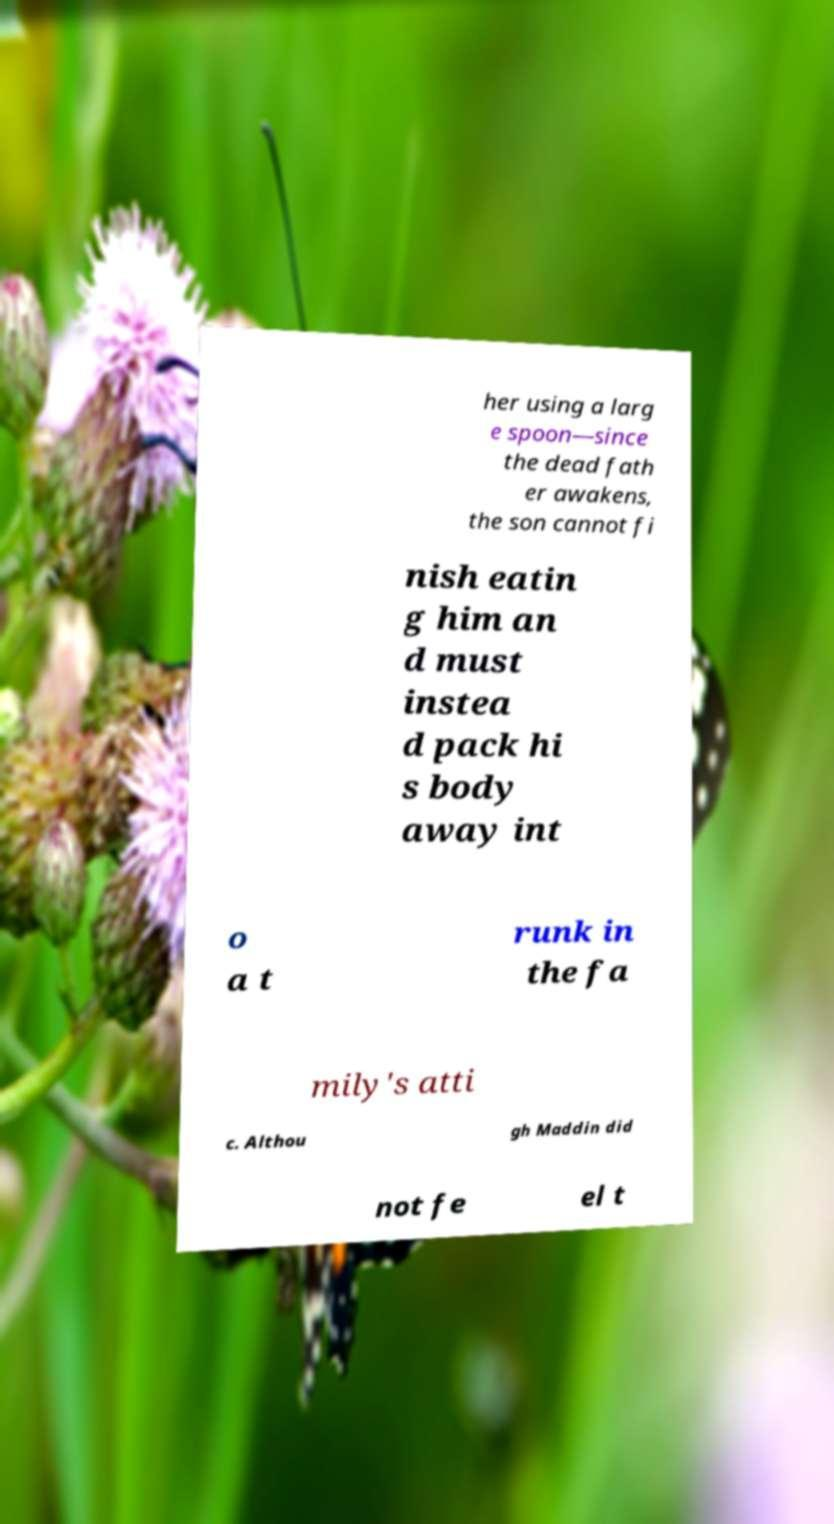I need the written content from this picture converted into text. Can you do that? her using a larg e spoon—since the dead fath er awakens, the son cannot fi nish eatin g him an d must instea d pack hi s body away int o a t runk in the fa mily's atti c. Althou gh Maddin did not fe el t 